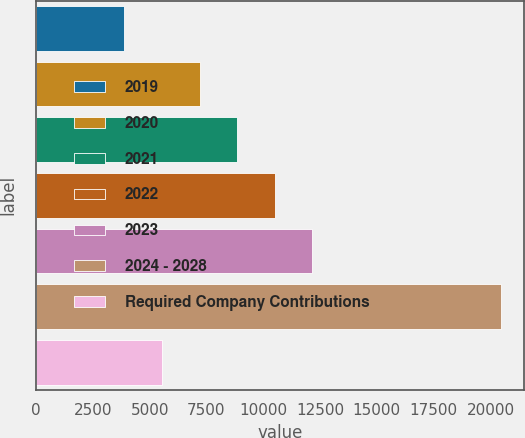<chart> <loc_0><loc_0><loc_500><loc_500><bar_chart><fcel>2019<fcel>2020<fcel>2021<fcel>2022<fcel>2023<fcel>2024 - 2028<fcel>Required Company Contributions<nl><fcel>3881<fcel>7194.6<fcel>8851.4<fcel>10508.2<fcel>12165<fcel>20449<fcel>5537.8<nl></chart> 